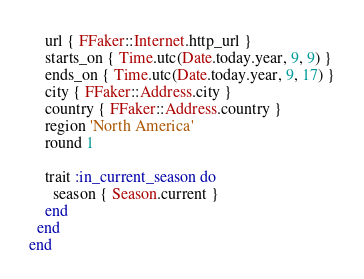Convert code to text. <code><loc_0><loc_0><loc_500><loc_500><_Ruby_>    url { FFaker::Internet.http_url }
    starts_on { Time.utc(Date.today.year, 9, 9) }
    ends_on { Time.utc(Date.today.year, 9, 17) }
    city { FFaker::Address.city }
    country { FFaker::Address.country }
    region 'North America'
    round 1

    trait :in_current_season do
      season { Season.current }
    end
  end
end
</code> 